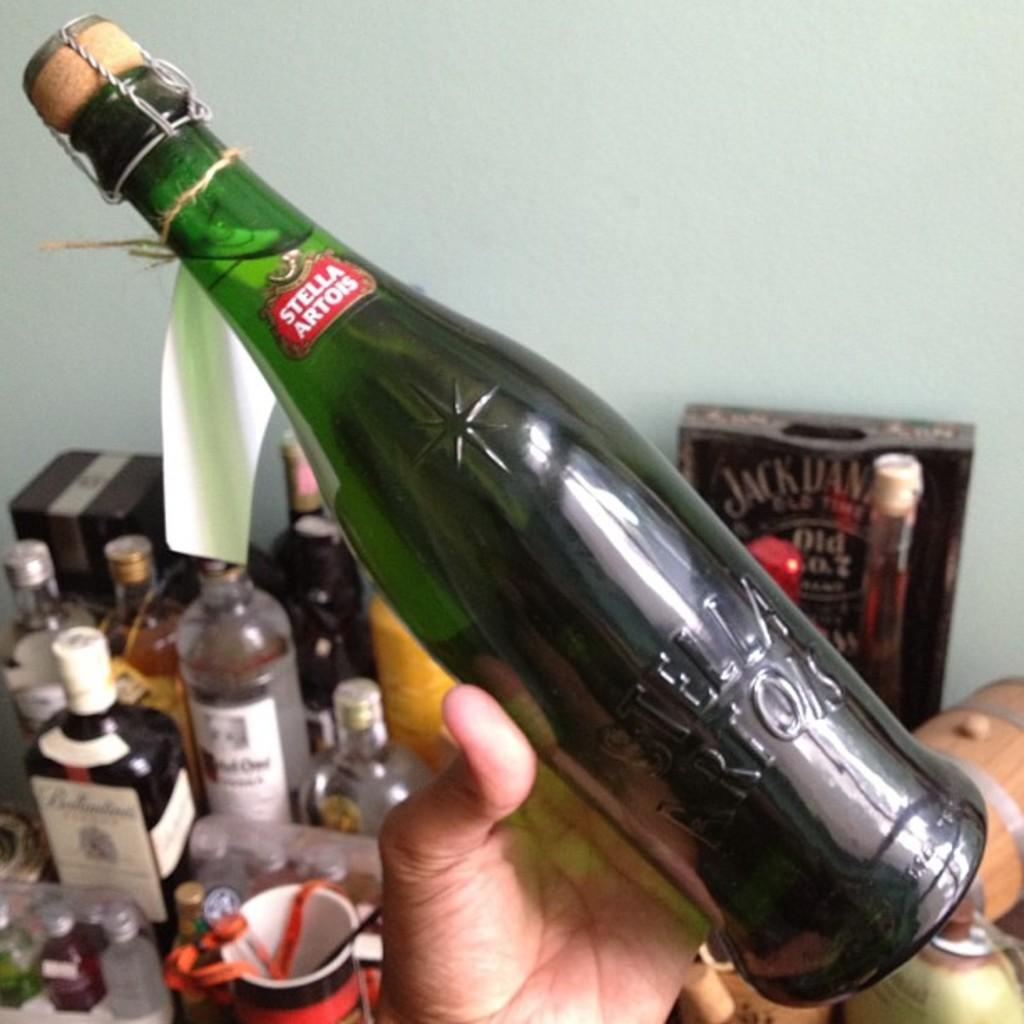What is the person in the image holding? The person is holding a wine bottle in the image. What else can be seen on the table in the image? There are multiple wine bottles on the table in the image. What type of needle is the secretary using to calculate the wine inventory in the image? There is no needle or secretary present in the image, and the image does not depict any calculations or inventory management. 